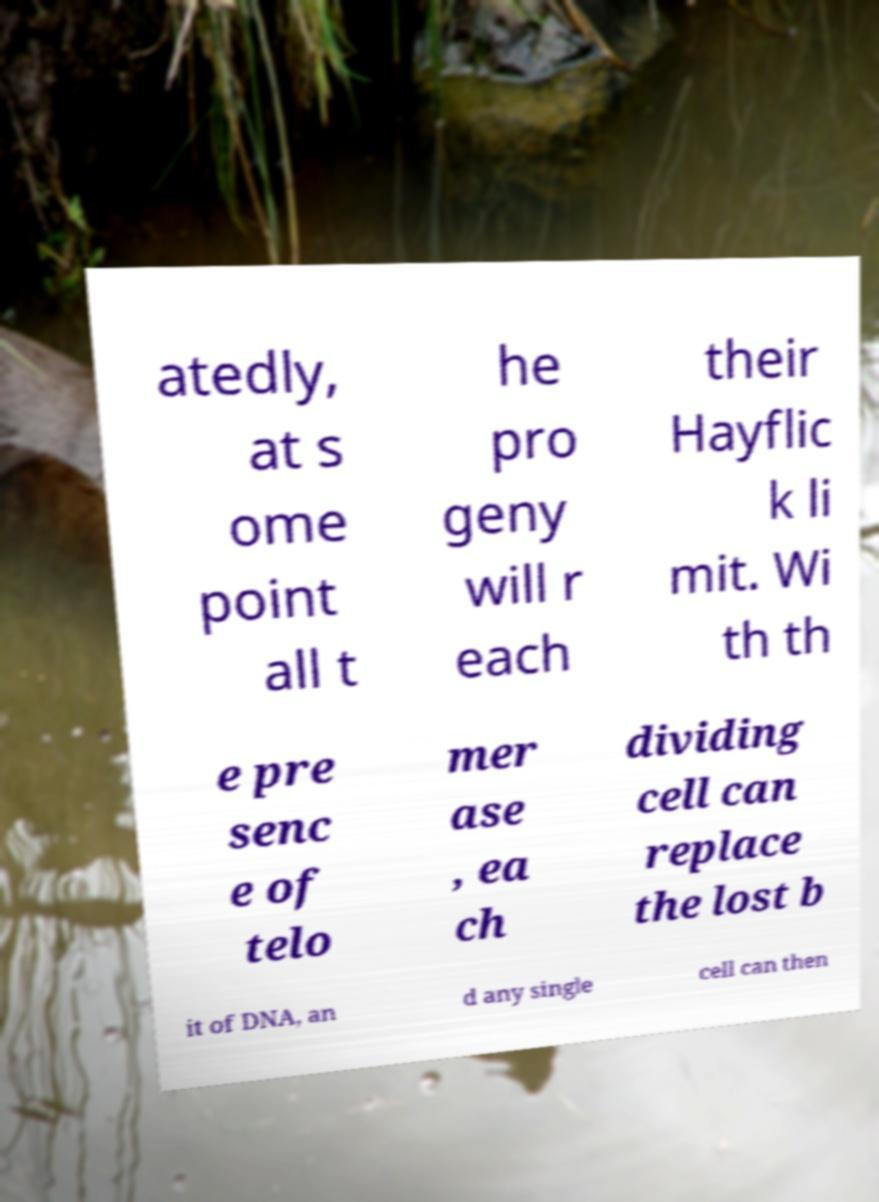Can you accurately transcribe the text from the provided image for me? atedly, at s ome point all t he pro geny will r each their Hayflic k li mit. Wi th th e pre senc e of telo mer ase , ea ch dividing cell can replace the lost b it of DNA, an d any single cell can then 